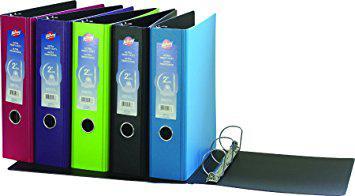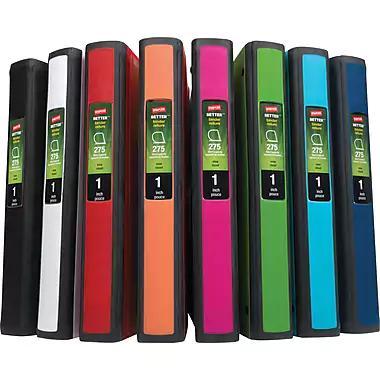The first image is the image on the left, the second image is the image on the right. Evaluate the accuracy of this statement regarding the images: "There are five binders in the image pair.". Is it true? Answer yes or no. No. The first image is the image on the left, the second image is the image on the right. Given the left and right images, does the statement "One image contains a single upright binder, and the other contains a row of four binders." hold true? Answer yes or no. No. 